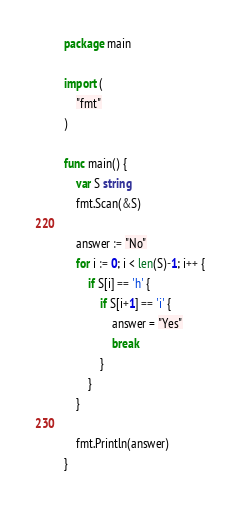<code> <loc_0><loc_0><loc_500><loc_500><_Go_>package main

import (
	"fmt"
)

func main() {
	var S string
	fmt.Scan(&S)

	answer := "No"
	for i := 0; i < len(S)-1; i++ {
		if S[i] == 'h' {
			if S[i+1] == 'i' {
				answer = "Yes"
				break
			}
		}
	}

	fmt.Println(answer)
}
</code> 